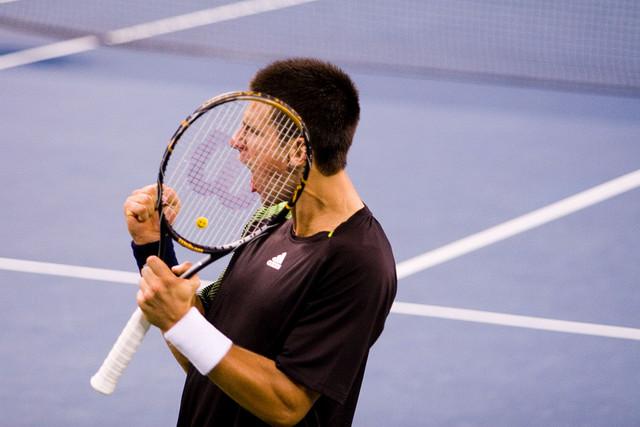Is he excited?
Be succinct. Yes. What sport is this?
Quick response, please. Tennis. What color is his hair?
Be succinct. Brown. 